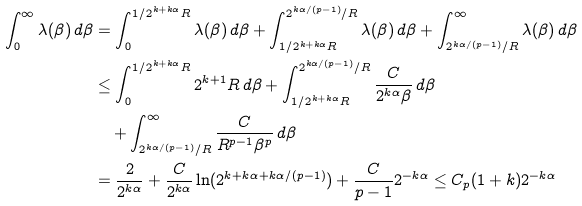Convert formula to latex. <formula><loc_0><loc_0><loc_500><loc_500>\int _ { 0 } ^ { \infty } \lambda ( \beta ) \, d \beta & = \int _ { 0 } ^ { 1 / 2 ^ { k + k \alpha } R } \lambda ( \beta ) \, d \beta + \int _ { 1 / 2 ^ { k + k \alpha } R } ^ { 2 ^ { k \alpha / ( p - 1 ) } / R } \lambda ( \beta ) \, d \beta + \int _ { 2 ^ { k \alpha / ( p - 1 ) } / R } ^ { \infty } \lambda ( \beta ) \, d \beta \\ & \leq \int _ { 0 } ^ { 1 / 2 ^ { k + k \alpha } R } 2 ^ { k + 1 } R \, d \beta + \int _ { 1 / 2 ^ { k + k \alpha } R } ^ { 2 ^ { k \alpha / ( p - 1 ) } / R } \frac { C } { 2 ^ { k \alpha } \beta } \, d \beta \\ & \quad + \int _ { 2 ^ { k \alpha / ( p - 1 ) } / R } ^ { \infty } \frac { C } { R ^ { p - 1 } \beta ^ { p } } \, d \beta \\ & = \frac { 2 } { 2 ^ { k \alpha } } + \frac { C } { 2 ^ { k \alpha } } \ln ( 2 ^ { k + k \alpha + k \alpha / ( p - 1 ) } ) + \frac { C } { p - 1 } 2 ^ { - k \alpha } \leq C _ { p } ( 1 + k ) 2 ^ { - k \alpha }</formula> 